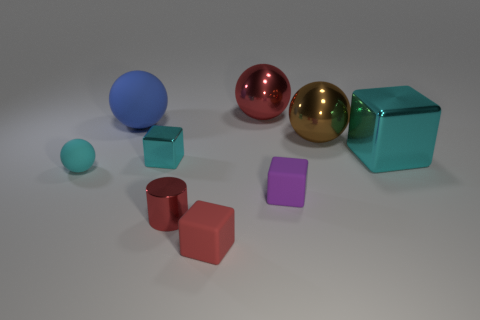What is the material of the big block that is the same color as the tiny sphere?
Give a very brief answer. Metal. How many big yellow rubber things have the same shape as the small cyan metallic object?
Offer a very short reply. 0. Are the red cube and the red thing behind the purple thing made of the same material?
Provide a succinct answer. No. There is a purple block that is the same size as the red shiny cylinder; what material is it?
Provide a succinct answer. Rubber. Is there a object that has the same size as the brown sphere?
Give a very brief answer. Yes. What is the shape of the cyan matte object that is the same size as the red metal cylinder?
Offer a terse response. Sphere. How many other things are the same color as the metal cylinder?
Your response must be concise. 2. What shape is the object that is both left of the tiny cyan metal thing and in front of the large brown sphere?
Keep it short and to the point. Sphere. There is a cyan shiny thing left of the shiny thing that is behind the large matte sphere; are there any cyan blocks that are behind it?
Offer a very short reply. Yes. How many other things are made of the same material as the big brown ball?
Offer a terse response. 4. 